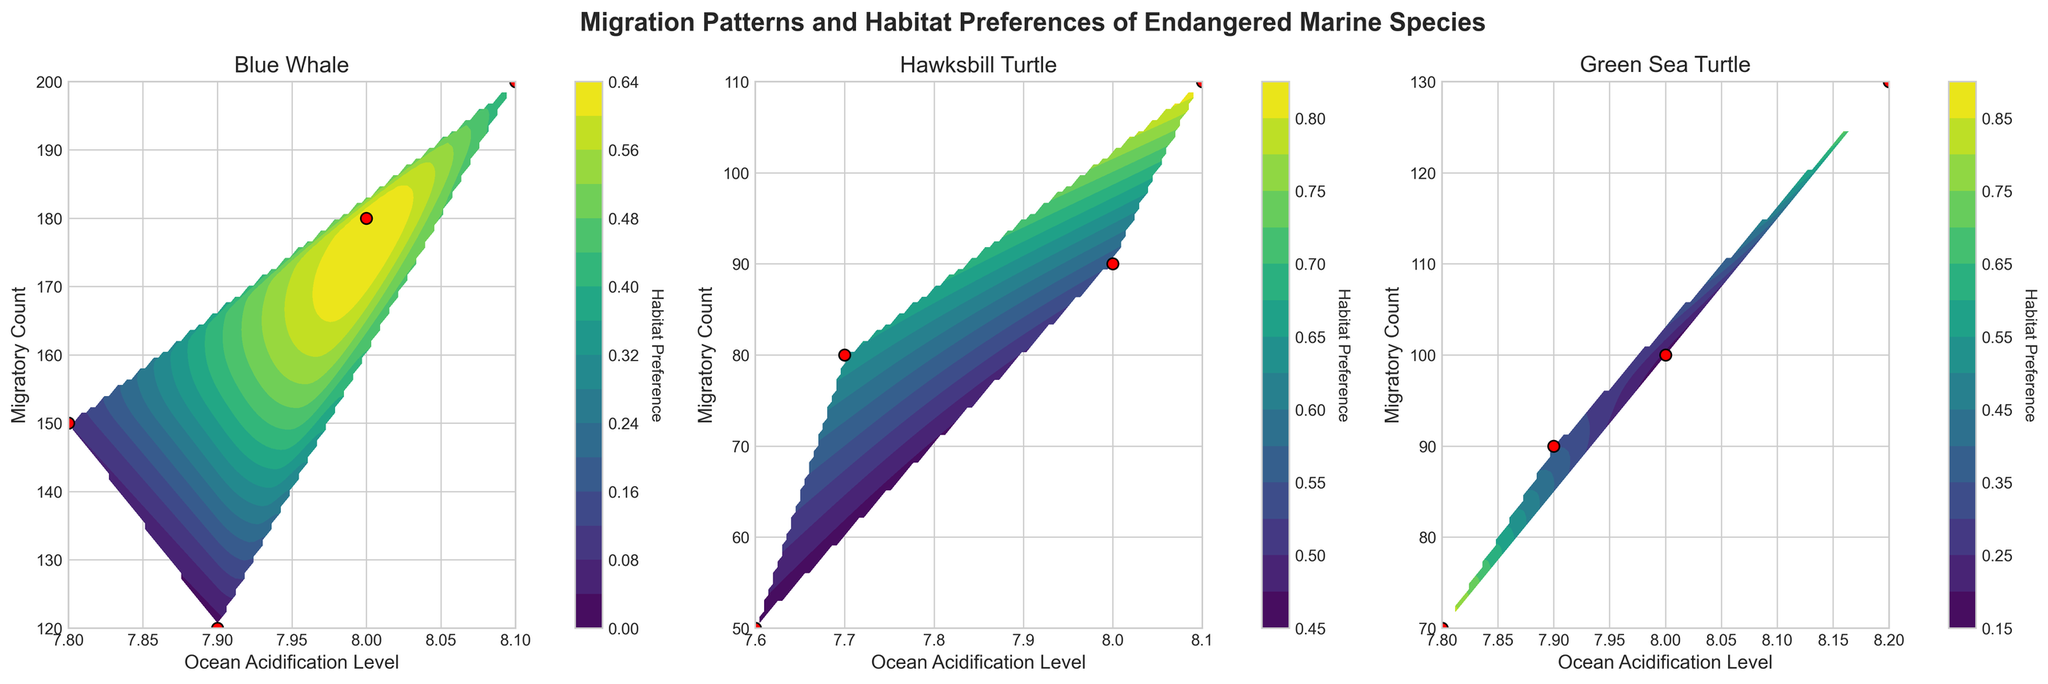What is the title of the figure? The title of the figure can be found at the top, which gives an overall description of what the figure represents. In this case, the title reads 'Migration Patterns and Habitat Preferences of Endangered Marine Species'.
Answer: Migration Patterns and Habitat Preferences of Endangered Marine Species How many subplots are there in the figure? By visually counting the number of distinct plots within the figure, you can see that there are three subplots.
Answer: 3 What are the species names shown in the subplots? The subplots are each labeled with the names of the species. From left to right, these names are 'Blue Whale', 'Hawksbill Turtle', and 'Green Sea Turtle'.
Answer: Blue Whale, Hawksbill Turtle, Green Sea Turtle Which species seems to have the highest range of migratory count under varying ocean acidification levels? By observing the range of migratory counts on the y-axes of each subplot, it is noticeable that the 'Blue Whale' subplot shows the highest range from 50 to 200, compared to the other species.
Answer: Blue Whale What color represents the scatter plot points in each subplot? By examining the scatter plot points in each subplot, it can be seen that the points are colored in red.
Answer: Red What is the y-axis label for the subplots? Each subplot features a y-axis, and the label for this axis can be identified as 'Migratory Count'.
Answer: Migratory Count How is the habitat preference information being represented in the plots? The habitat preference is visually represented using a color gradient in the contour plots, with a color bar provided for reference.
Answer: Using color gradient What does the contour plot indicate in terms of habitat preference variability for Blue Whales? Observing the 'Blue Whale' subplot, the contour plot with varying colors indicates different levels of habitat preference, showing there is variability based on ocean acidification levels and migratory count.
Answer: Indicates variability For Hawksbill Turtles, was there a higher migratory count at ocean acidification level 7.7 or 8.1? By looking at the specific points on the 'Hawksbill Turtle' subplot, it's clear that the migratory count at 8.1 is higher (110) compared to 7.7 (80).
Answer: 8.1 Do Green Sea Turtles prefer habitats more at ocean acidification levels around 8.0 or 7.8 according to the migratory count? The contour plot for 'Green Sea Turtles' shows higher migratory counts at around ocean acidification level 8.0 compared to 7.8, as indicated by the scatter points and contour shade.
Answer: Around 8.0 